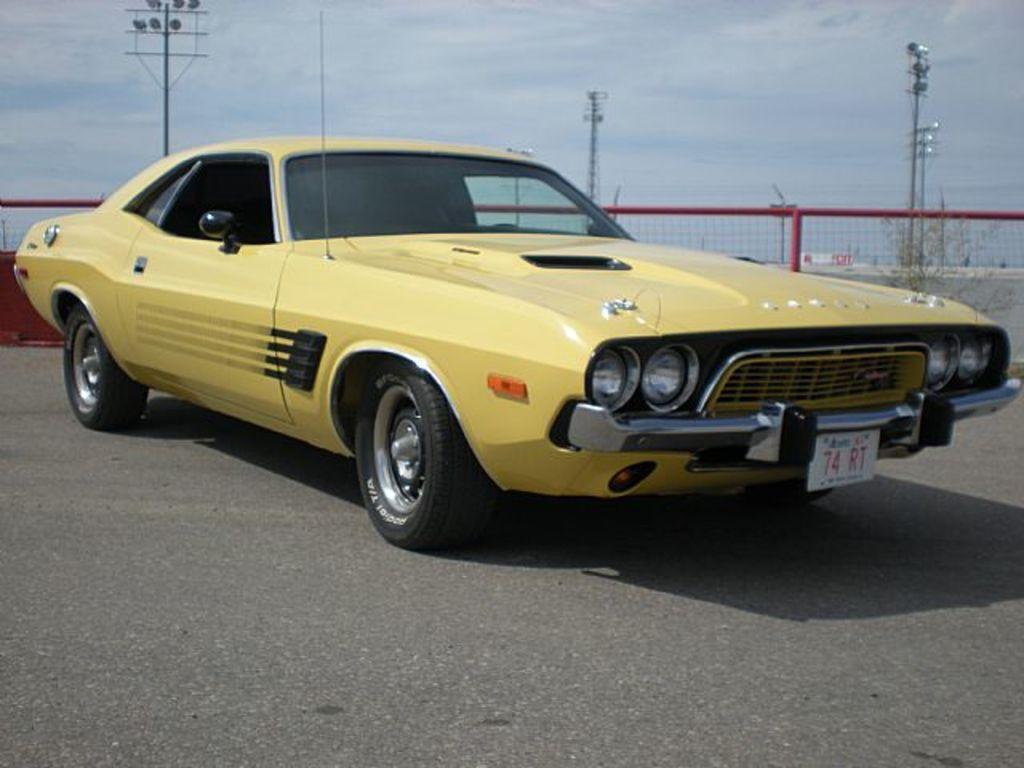Describe this image in one or two sentences. In this picture, we can see a vehicle, road, fencing, ground, poles, lights, towers, some red color object on the left side of the picture, and the sky. 